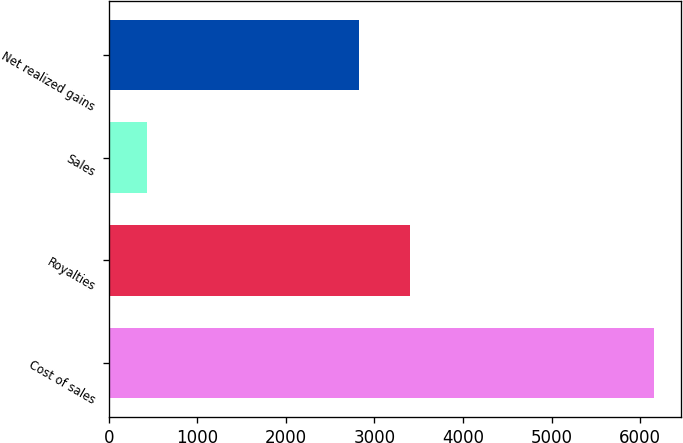Convert chart to OTSL. <chart><loc_0><loc_0><loc_500><loc_500><bar_chart><fcel>Cost of sales<fcel>Royalties<fcel>Sales<fcel>Net realized gains<nl><fcel>6158<fcel>3399.2<fcel>436<fcel>2827<nl></chart> 